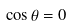Convert formula to latex. <formula><loc_0><loc_0><loc_500><loc_500>\cos { \theta } = 0</formula> 